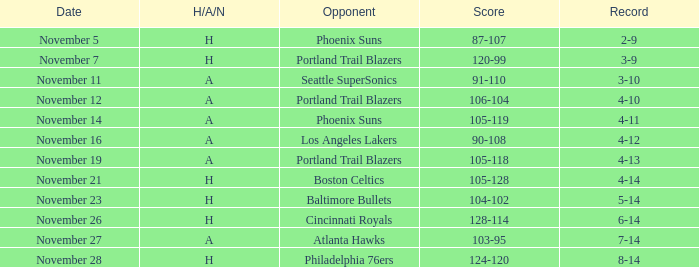Which opposing team did the cavaliers encounter with a 3-9 record? Portland Trail Blazers. 